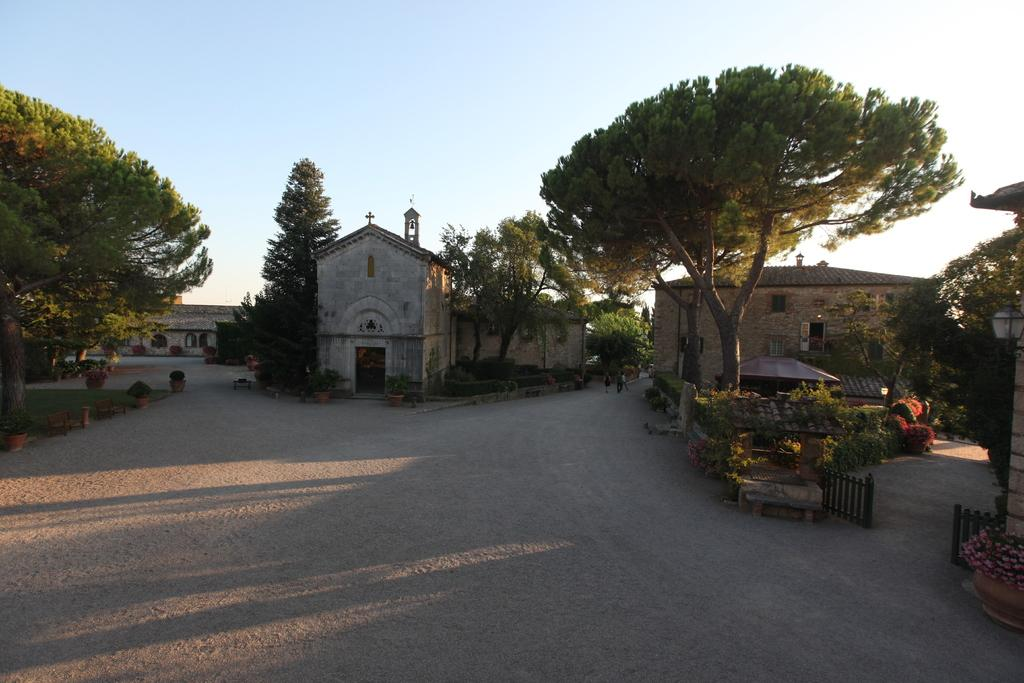What type of structures can be seen in the image? There are buildings in the image. What architectural features can be observed on the buildings? Windows are visible in the image. What type of vegetation is present in the image? There are trees in the image. What type of seating is available in the image? There are benches in the image. What type of decorative items can be seen in the image? There are flower pots and flowers in the image. Who or what is present in the image? There are people in the image. What part of the natural environment is visible in the image? The sky is visible in the image. Can you tell me how many coats are hanging on the trees in the image? There are no coats hanging on the trees in the image; only flowers and trees are present. What type of nut is being cracked by the people in the image? There are no nuts or nut-cracking activities depicted in the image. 